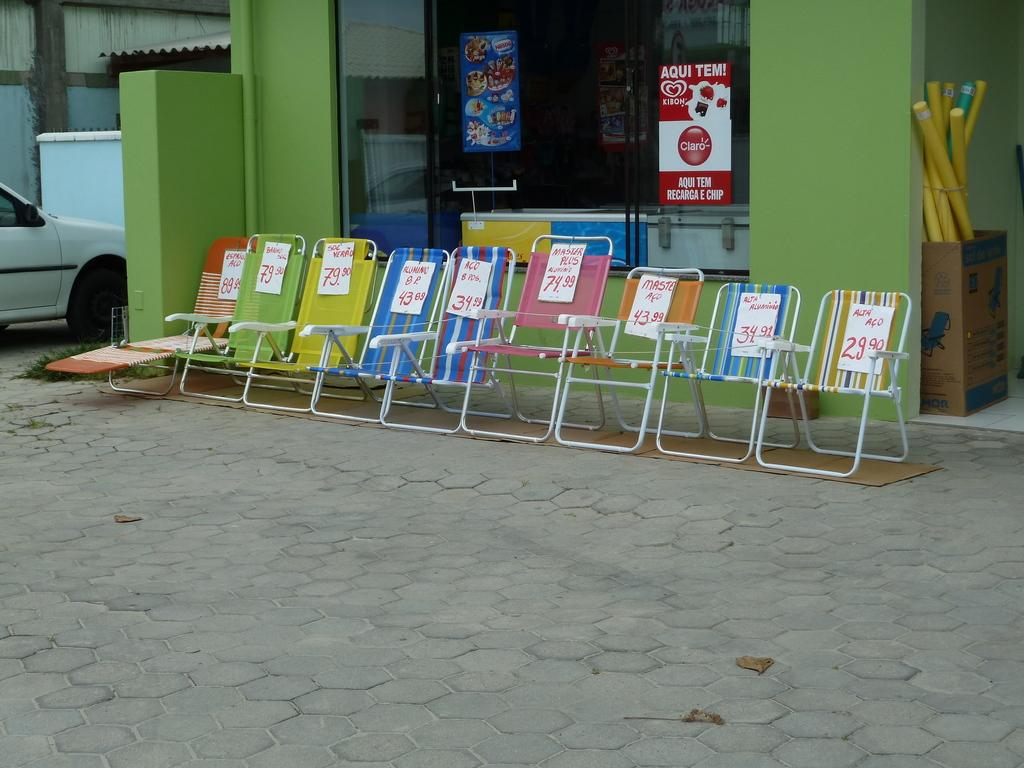What type of furniture is in front of the store in the image? There are chairs in front of the store in the image. What is on the right side of the image? There is a cardboard on the right side of the image with sticks in it. What can be seen on the left side of the image? There is a car on the left side of the image on the road. What scent is emanating from the cardboard on the right side of the image? There is no information about a scent in the image; it only mentions a cardboard with sticks in it. How many squirrels are sitting on the chairs in front of the store? There are no squirrels present in the image; it only shows chairs in front of a store. 